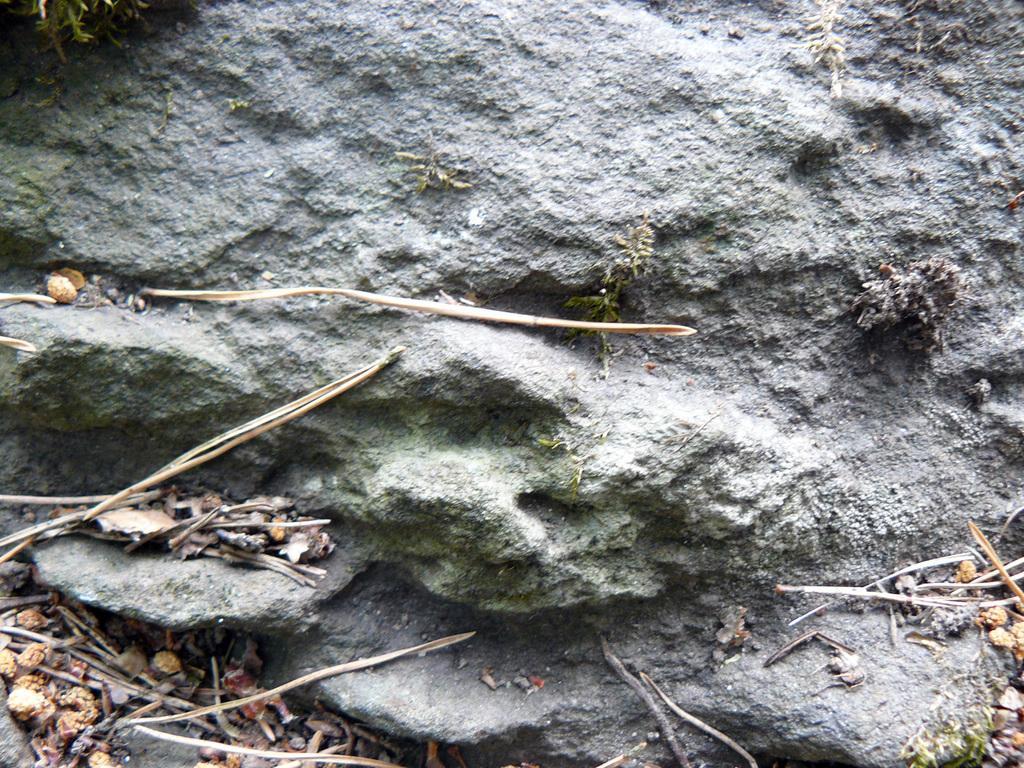In one or two sentences, can you explain what this image depicts? In this image we can see rock surface, seeds, and sticks. 